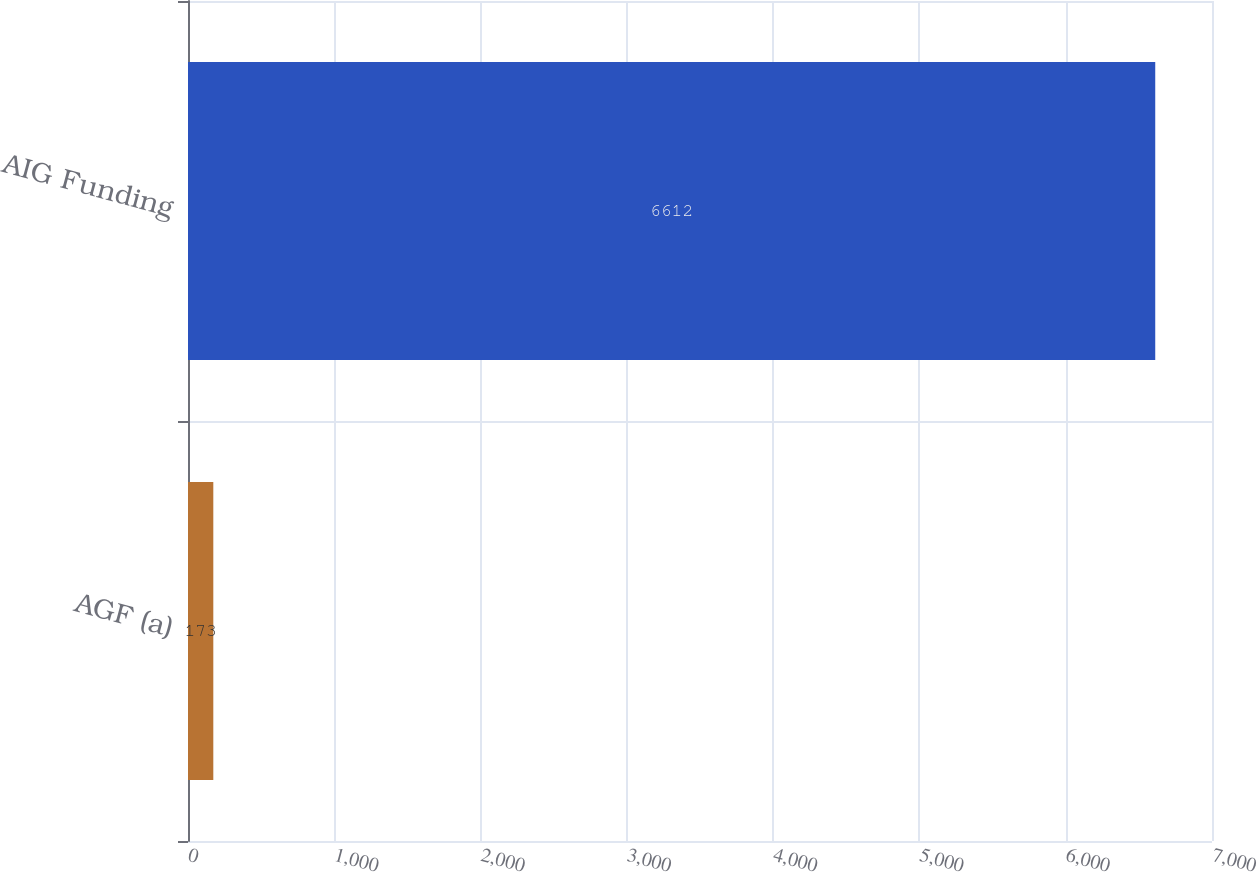Convert chart to OTSL. <chart><loc_0><loc_0><loc_500><loc_500><bar_chart><fcel>AGF (a)<fcel>AIG Funding<nl><fcel>173<fcel>6612<nl></chart> 